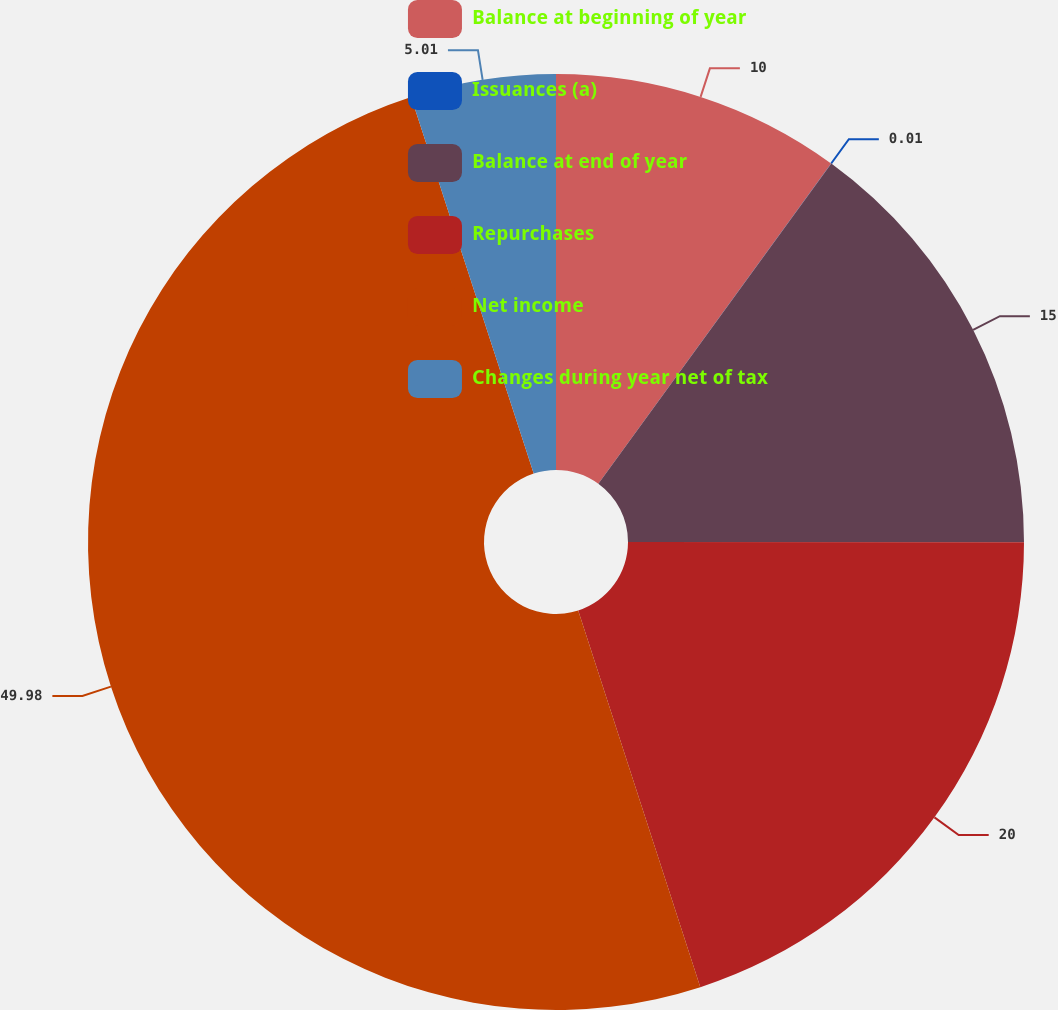Convert chart. <chart><loc_0><loc_0><loc_500><loc_500><pie_chart><fcel>Balance at beginning of year<fcel>Issuances (a)<fcel>Balance at end of year<fcel>Repurchases<fcel>Net income<fcel>Changes during year net of tax<nl><fcel>10.0%<fcel>0.01%<fcel>15.0%<fcel>20.0%<fcel>49.98%<fcel>5.01%<nl></chart> 